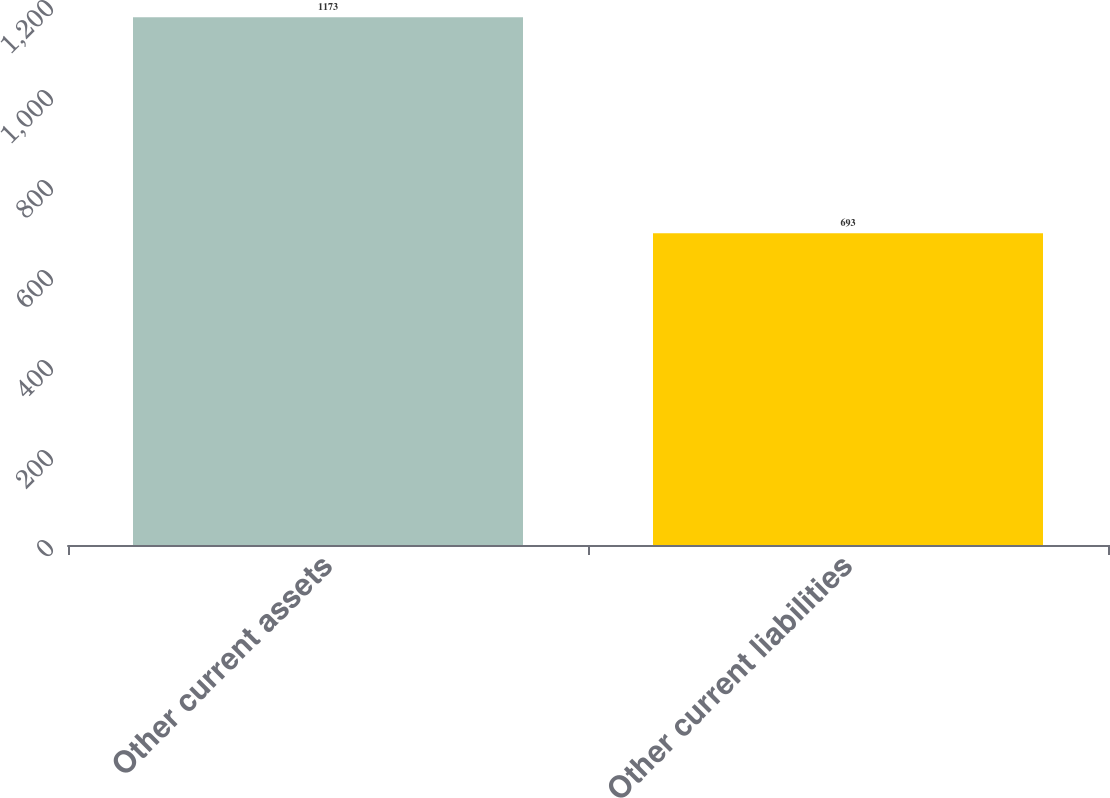Convert chart. <chart><loc_0><loc_0><loc_500><loc_500><bar_chart><fcel>Other current assets<fcel>Other current liabilities<nl><fcel>1173<fcel>693<nl></chart> 